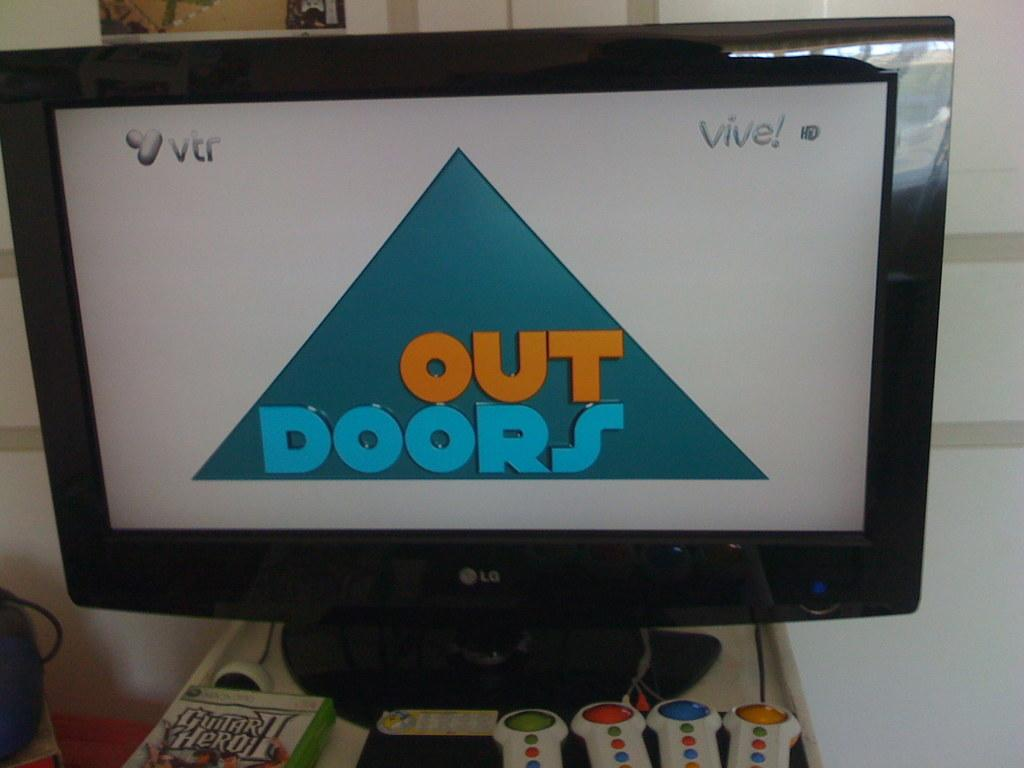<image>
Present a compact description of the photo's key features. An LG computer monitor shows a display screen that reads "outdoors" 